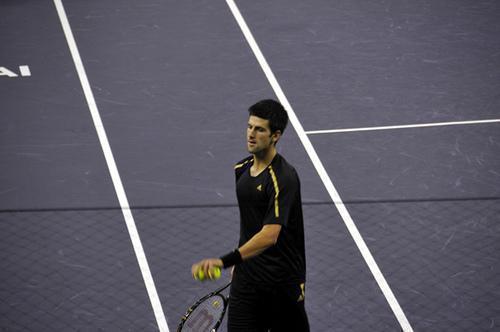What is the person holding in their hands?
Answer the question by selecting the correct answer among the 4 following choices.
Options: Tennis balls, straws, rocks, doves. Tennis balls. 